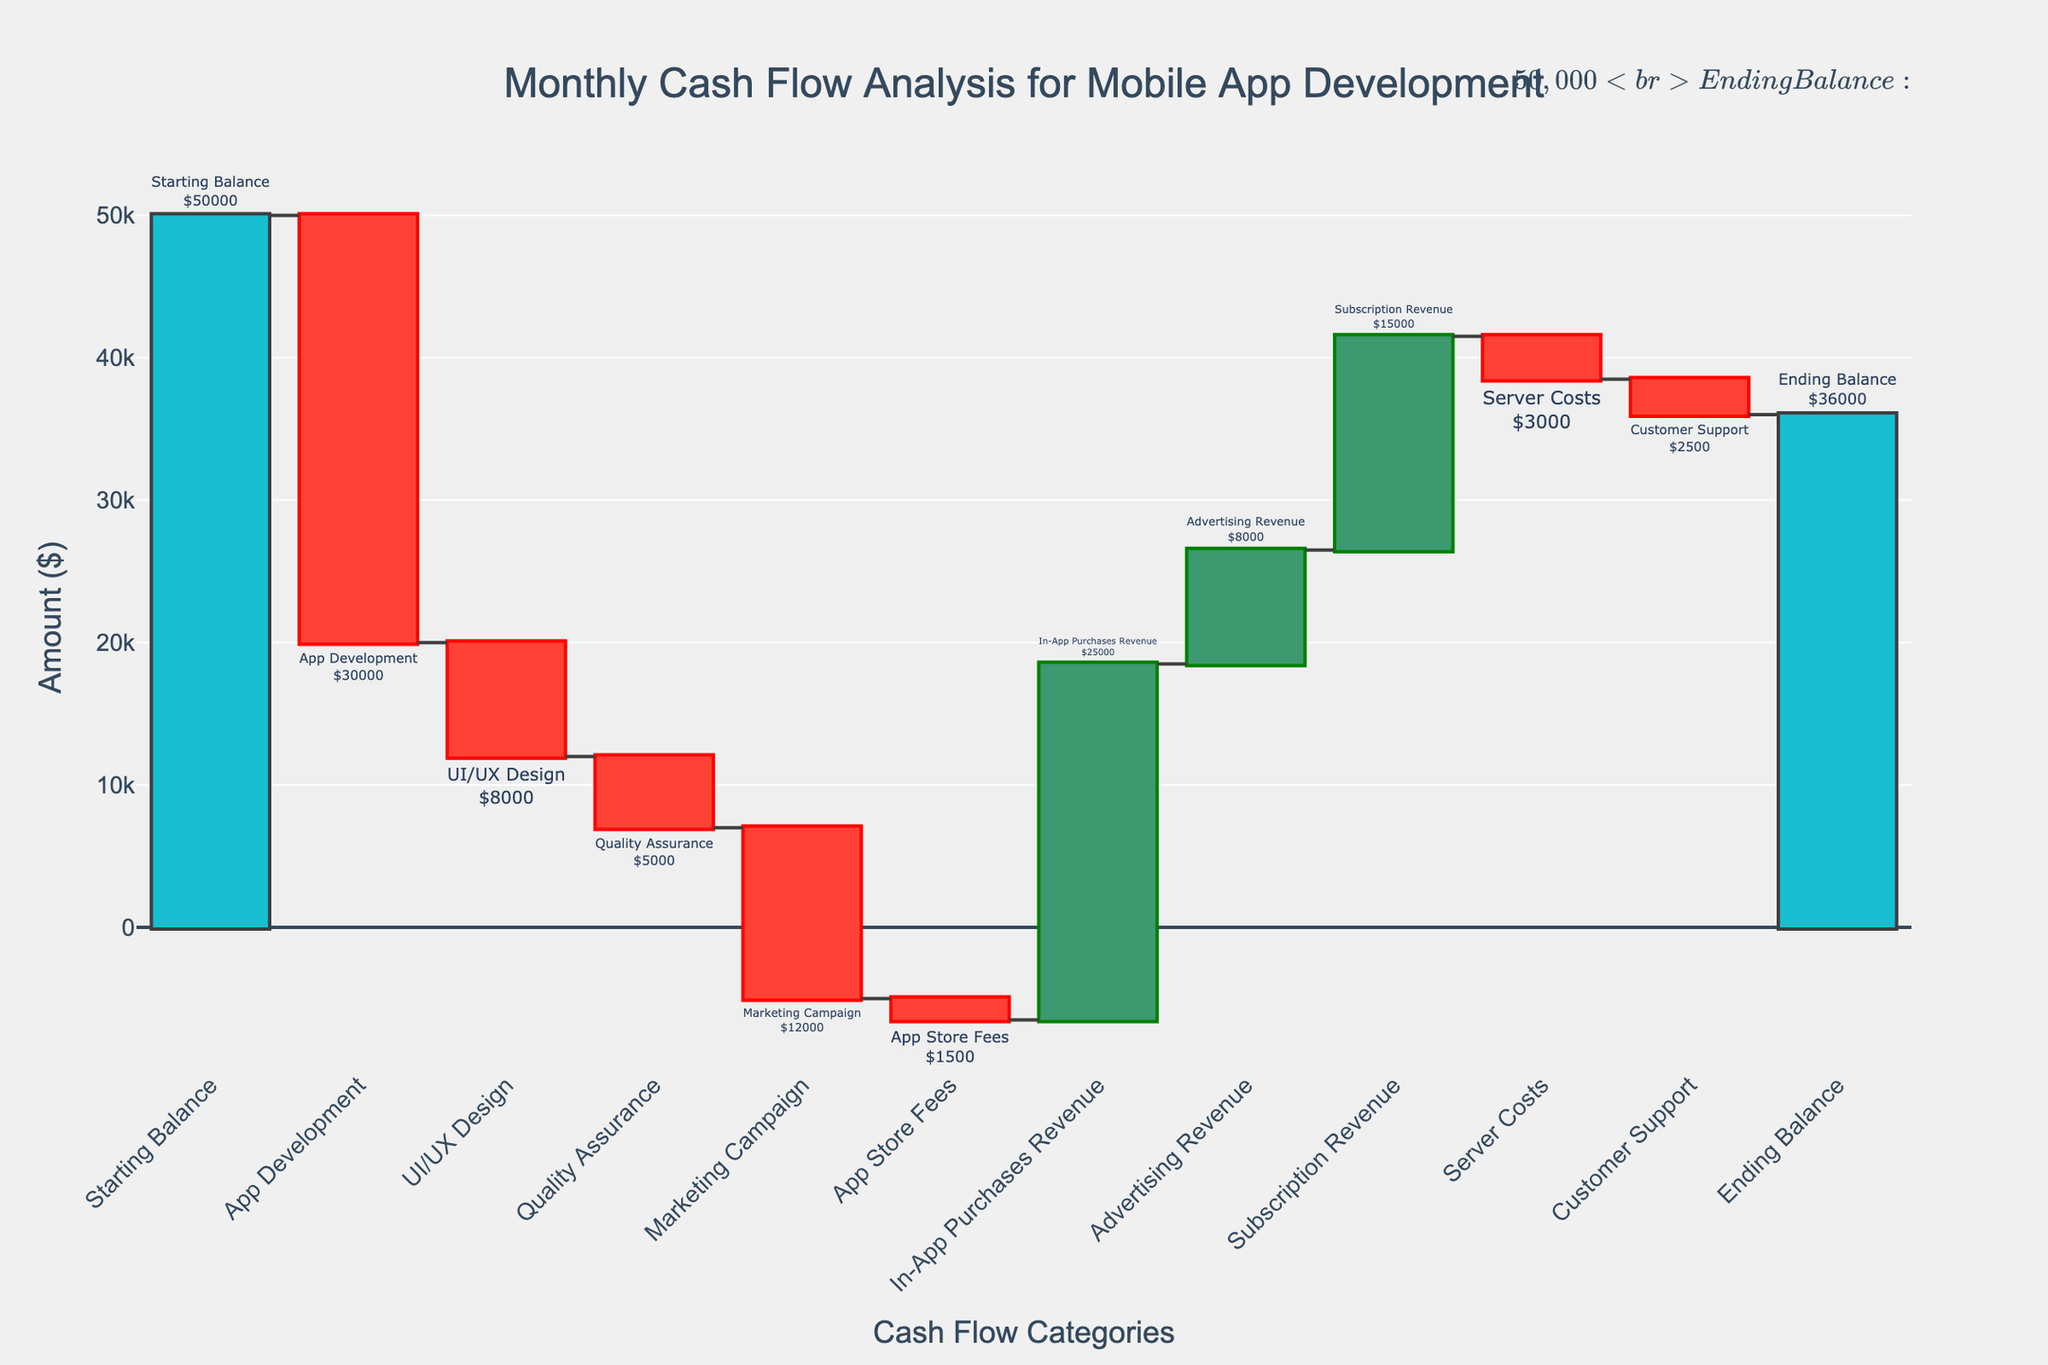What is the title of the chart? The title of the chart is usually located at the top and serves as a brief description of the data being presented. In this case, it reads "Monthly Cash Flow Analysis for Mobile App Development".
Answer: Monthly Cash Flow Analysis for Mobile App Development How many categories of cash flow are included in the analysis? To determine the number of categories, count the distinct labels along the x-axis. Categories include "Starting Balance", "App Development", "UI/UX Design", "Quality Assurance", "Marketing Campaign", "App Store Fees", "In-App Purchases Revenue", "Advertising Revenue", "Subscription Revenue", "Server Costs", "Customer Support", and "Ending Balance". This totals to 12 categories.
Answer: 12 Which category contributes the most to cash inflow and how much is it? Identify the category with the highest positive value by looking at the heights of the bars that extend in the positive direction. "In-App Purchases Revenue" contributes $25,000 in cash inflow, which is the highest.
Answer: In-App Purchases Revenue, $25,000 What is the net impact of "Quality Assurance" and "Marketing Campaign" costs combined? To find the combined impact, sum the negative values of these two categories. "Quality Assurance" costs $5,000 and "Marketing Campaign" costs $12,000, making the net impact $-5,000 + $-12,000 = $-17,000.
Answer: -$17,000 By how much does the "App Development" cost exceed the "UI/UX Design" cost? Subtract the "UI/UX Design" cost from the "App Development" cost. "App Development" costs $30,000 and "UI/UX Design" costs $8,000, so the difference is $30,000 - $8,000 = $22,000.
Answer: $22,000 Which category has the smallest cash outflow and what is the amount? Identify the category with the smallest negative value. "App Store Fees" has the smallest cash outflow, which is $1,500.
Answer: App Store Fees, $1,500 What is the impact of server and customer support costs combined? Sum the negative values of the "Server Costs" and "Customer Support" categories. "Server Costs" is $3,000 and "Customer Support" is $2,500, so the combined impact is $-3,000 + $-2,500 = $-5,500.
Answer: -$5,500 What is the overall net cash flow for all categories excluding the starting and ending balances? Calculate the net sum of all the entries between "Starting Balance" and "Ending Balance". Sum the negative values and the positive values separately and then combine them: Negative values: -$30000 (App Development) - $8000 (UI/UX Design) - $5000 (Quality Assurance) - $12000 (Marketing Campaign) - $1500 (App Store Fees) - $3000 (Server Costs) - $2500 (Customer Support) = -$62,000, Positive values: $25000 (In-App Purchases Revenue) + $8000 (Advertising Revenue) + $15000 (Subscription Revenue) = $48,000, Net cash flow: $48,000 - $62,000 = -$14,000.
Answer: -$14,000 How does the total cash inflow compare to the total cash outflow? To compare, sum the positive values and the negative values separately. Total cash inflow: $25,000 (In-App Purchases Revenue) + $8,000 (Advertising Revenue) + $15,000 (Subscription Revenue) = $48,000, Total cash outflow: $30,000 (App Development) + $8,000 (UI/UX Design) + $5,000 (Quality Assurance) + $12,000 (Marketing Campaign) + $1,500 (App Store Fees) + $3,000 (Server Costs) + $2,500 (Customer Support) = $62,000, Total cash inflow: $48,000, Total cash outflow: $62,000, hence cash outflow exceeds the cash inflow by $62,000 - $48,000 = $14,000.
Answer: Cash outflow exceeds inflow by $14,000 